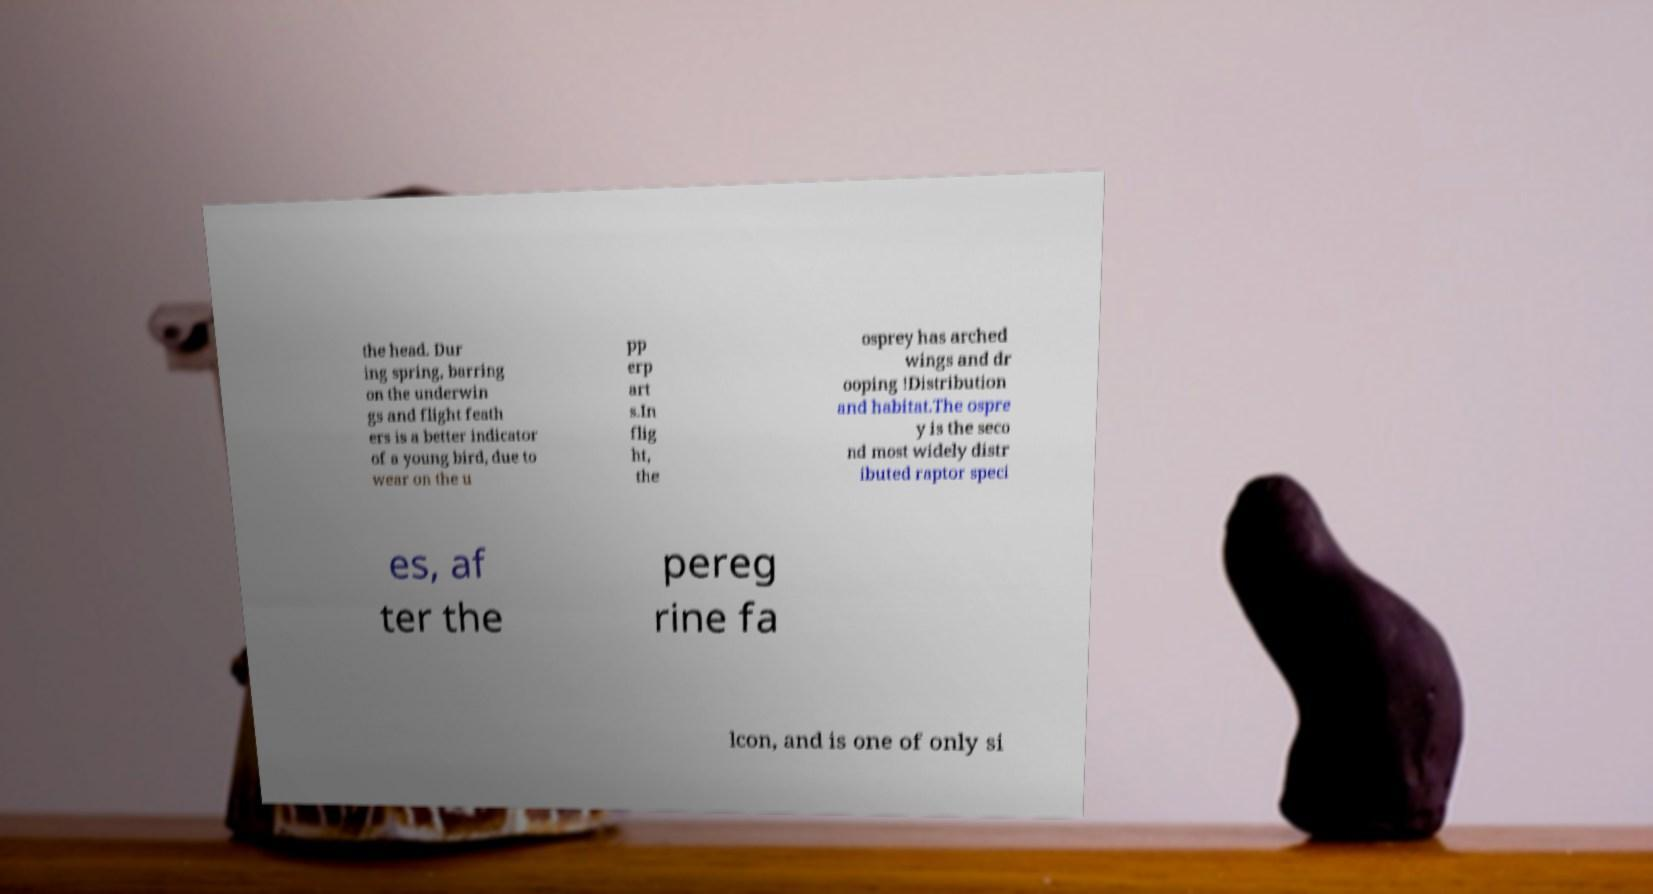Can you accurately transcribe the text from the provided image for me? the head. Dur ing spring, barring on the underwin gs and flight feath ers is a better indicator of a young bird, due to wear on the u pp erp art s.In flig ht, the osprey has arched wings and dr ooping !Distribution and habitat.The ospre y is the seco nd most widely distr ibuted raptor speci es, af ter the pereg rine fa lcon, and is one of only si 